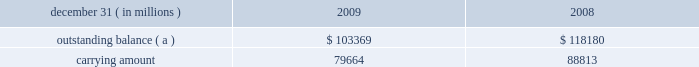Notes to consolidated financial statements jpmorgan chase & co./2009 annual report 204 on the amount of interest income recognized in the firm 2019s consolidated statements of income since that date .
( b ) other changes in expected cash flows include the net impact of changes in esti- mated prepayments and reclassifications to the nonaccretable difference .
On a quarterly basis , the firm updates the amount of loan principal and interest cash flows expected to be collected , incorporating assumptions regarding default rates , loss severities , the amounts and timing of prepayments and other factors that are reflective of current market conditions .
Probable decreases in expected loan principal cash flows trigger the recognition of impairment , which is then measured as the present value of the expected principal loss plus any related foregone interest cash flows discounted at the pool 2019s effective interest rate .
Impairments that occur after the acquisition date are recognized through the provision and allow- ance for loan losses .
Probable and significant increases in expected principal cash flows would first reverse any previously recorded allowance for loan losses ; any remaining increases are recognized prospectively as interest income .
The impacts of ( i ) prepayments , ( ii ) changes in variable interest rates , and ( iii ) any other changes in the timing of expected cash flows are recognized prospectively as adjustments to interest income .
Disposals of loans , which may include sales of loans , receipt of payments in full by the borrower , or foreclosure , result in removal of the loan from the purchased credit-impaired portfolio .
If the timing and/or amounts of expected cash flows on these purchased credit-impaired loans were determined not to be rea- sonably estimable , no interest would be accreted and the loans would be reported as nonperforming loans ; however , since the timing and amounts of expected cash flows for these purchased credit-impaired loans are reasonably estimable , interest is being accreted and the loans are being reported as performing loans .
Charge-offs are not recorded on purchased credit-impaired loans until actual losses exceed the estimated losses that were recorded as purchase accounting adjustments at acquisition date .
To date , no charge-offs have been recorded for these loans .
Purchased credit-impaired loans acquired in the washington mu- tual transaction are reported in loans on the firm 2019s consolidated balance sheets .
In 2009 , an allowance for loan losses of $ 1.6 billion was recorded for the prime mortgage and option arm pools of loans .
The net aggregate carrying amount of the pools that have an allowance for loan losses was $ 47.2 billion at december 31 , 2009 .
This allowance for loan losses is reported as a reduction of the carrying amount of the loans in the table below .
The table below provides additional information about these pur- chased credit-impaired consumer loans. .
( a ) represents the sum of contractual principal , interest and fees earned at the reporting date .
Purchased credit-impaired loans are also being modified under the mha programs and the firm 2019s other loss mitigation programs .
For these loans , the impact of the modification is incorporated into the firm 2019s quarterly assessment of whether a probable and/or signifi- cant change in estimated future cash flows has occurred , and the loans continue to be accounted for as and reported as purchased credit-impaired loans .
Foreclosed property the firm acquires property from borrowers through loan restructur- ings , workouts , and foreclosures , which is recorded in other assets on the consolidated balance sheets .
Property acquired may include real property ( e.g. , land , buildings , and fixtures ) and commercial and personal property ( e.g. , aircraft , railcars , and ships ) .
Acquired property is valued at fair value less costs to sell at acquisition .
Each quarter the fair value of the acquired property is reviewed and adjusted , if necessary .
Any adjustments to fair value in the first 90 days are charged to the allowance for loan losses and thereafter adjustments are charged/credited to noninterest revenue 2013other .
Operating expense , such as real estate taxes and maintenance , are charged to other expense .
Note 14 2013 allowance for credit losses the allowance for loan losses includes an asset-specific component , a formula-based component and a component related to purchased credit-impaired loans .
The asset-specific component relates to loans considered to be impaired , which includes any loans that have been modified in a troubled debt restructuring as well as risk-rated loans that have been placed on nonaccrual status .
An asset-specific allowance for impaired loans is established when the loan 2019s discounted cash flows ( or , when available , the loan 2019s observable market price ) is lower than the recorded investment in the loan .
To compute the asset-specific component of the allowance , larger loans are evaluated individually , while smaller loans are evaluated as pools using historical loss experience for the respective class of assets .
Risk-rated loans ( primarily wholesale loans ) are pooled by risk rating , while scored loans ( i.e. , consumer loans ) are pooled by product type .
The firm generally measures the asset-specific allowance as the difference between the recorded investment in the loan and the present value of the cash flows expected to be collected , dis- counted at the loan 2019s original effective interest rate .
Subsequent changes in measured impairment due to the impact of discounting are reported as an adjustment to the provision for loan losses , not as an adjustment to interest income .
An asset-specific allowance for an impaired loan with an observable market price is measured as the difference between the recorded investment in the loan and the loan 2019s fair value .
Certain impaired loans that are determined to be collateral- dependent are charged-off to the fair value of the collateral less costs to sell .
When collateral-dependent commercial real-estate loans are determined to be impaired , updated appraisals are typi- cally obtained and updated every six to twelve months .
The firm also considers both borrower- and market-specific factors , which .
What was the ratio of the allowance for loan losses that was recorded for the prime mortgage to the net aggregate carrying amount of the pools? 
Computations: (1.6 / 47.2)
Answer: 0.0339. Notes to consolidated financial statements jpmorgan chase & co./2009 annual report 204 on the amount of interest income recognized in the firm 2019s consolidated statements of income since that date .
( b ) other changes in expected cash flows include the net impact of changes in esti- mated prepayments and reclassifications to the nonaccretable difference .
On a quarterly basis , the firm updates the amount of loan principal and interest cash flows expected to be collected , incorporating assumptions regarding default rates , loss severities , the amounts and timing of prepayments and other factors that are reflective of current market conditions .
Probable decreases in expected loan principal cash flows trigger the recognition of impairment , which is then measured as the present value of the expected principal loss plus any related foregone interest cash flows discounted at the pool 2019s effective interest rate .
Impairments that occur after the acquisition date are recognized through the provision and allow- ance for loan losses .
Probable and significant increases in expected principal cash flows would first reverse any previously recorded allowance for loan losses ; any remaining increases are recognized prospectively as interest income .
The impacts of ( i ) prepayments , ( ii ) changes in variable interest rates , and ( iii ) any other changes in the timing of expected cash flows are recognized prospectively as adjustments to interest income .
Disposals of loans , which may include sales of loans , receipt of payments in full by the borrower , or foreclosure , result in removal of the loan from the purchased credit-impaired portfolio .
If the timing and/or amounts of expected cash flows on these purchased credit-impaired loans were determined not to be rea- sonably estimable , no interest would be accreted and the loans would be reported as nonperforming loans ; however , since the timing and amounts of expected cash flows for these purchased credit-impaired loans are reasonably estimable , interest is being accreted and the loans are being reported as performing loans .
Charge-offs are not recorded on purchased credit-impaired loans until actual losses exceed the estimated losses that were recorded as purchase accounting adjustments at acquisition date .
To date , no charge-offs have been recorded for these loans .
Purchased credit-impaired loans acquired in the washington mu- tual transaction are reported in loans on the firm 2019s consolidated balance sheets .
In 2009 , an allowance for loan losses of $ 1.6 billion was recorded for the prime mortgage and option arm pools of loans .
The net aggregate carrying amount of the pools that have an allowance for loan losses was $ 47.2 billion at december 31 , 2009 .
This allowance for loan losses is reported as a reduction of the carrying amount of the loans in the table below .
The table below provides additional information about these pur- chased credit-impaired consumer loans. .
( a ) represents the sum of contractual principal , interest and fees earned at the reporting date .
Purchased credit-impaired loans are also being modified under the mha programs and the firm 2019s other loss mitigation programs .
For these loans , the impact of the modification is incorporated into the firm 2019s quarterly assessment of whether a probable and/or signifi- cant change in estimated future cash flows has occurred , and the loans continue to be accounted for as and reported as purchased credit-impaired loans .
Foreclosed property the firm acquires property from borrowers through loan restructur- ings , workouts , and foreclosures , which is recorded in other assets on the consolidated balance sheets .
Property acquired may include real property ( e.g. , land , buildings , and fixtures ) and commercial and personal property ( e.g. , aircraft , railcars , and ships ) .
Acquired property is valued at fair value less costs to sell at acquisition .
Each quarter the fair value of the acquired property is reviewed and adjusted , if necessary .
Any adjustments to fair value in the first 90 days are charged to the allowance for loan losses and thereafter adjustments are charged/credited to noninterest revenue 2013other .
Operating expense , such as real estate taxes and maintenance , are charged to other expense .
Note 14 2013 allowance for credit losses the allowance for loan losses includes an asset-specific component , a formula-based component and a component related to purchased credit-impaired loans .
The asset-specific component relates to loans considered to be impaired , which includes any loans that have been modified in a troubled debt restructuring as well as risk-rated loans that have been placed on nonaccrual status .
An asset-specific allowance for impaired loans is established when the loan 2019s discounted cash flows ( or , when available , the loan 2019s observable market price ) is lower than the recorded investment in the loan .
To compute the asset-specific component of the allowance , larger loans are evaluated individually , while smaller loans are evaluated as pools using historical loss experience for the respective class of assets .
Risk-rated loans ( primarily wholesale loans ) are pooled by risk rating , while scored loans ( i.e. , consumer loans ) are pooled by product type .
The firm generally measures the asset-specific allowance as the difference between the recorded investment in the loan and the present value of the cash flows expected to be collected , dis- counted at the loan 2019s original effective interest rate .
Subsequent changes in measured impairment due to the impact of discounting are reported as an adjustment to the provision for loan losses , not as an adjustment to interest income .
An asset-specific allowance for an impaired loan with an observable market price is measured as the difference between the recorded investment in the loan and the loan 2019s fair value .
Certain impaired loans that are determined to be collateral- dependent are charged-off to the fair value of the collateral less costs to sell .
When collateral-dependent commercial real-estate loans are determined to be impaired , updated appraisals are typi- cally obtained and updated every six to twelve months .
The firm also considers both borrower- and market-specific factors , which .
In 2009 , what percentage of its net aggregate carrying amount did the firm record as its allowance for loan losses? 
Rationale: the firm's allowance for loan losses , $ 1.6 billion , came from an aggregate pool of $ 47.2 billion .
Computations: (1.6 / 47.2)
Answer: 0.0339. Notes to consolidated financial statements jpmorgan chase & co./2009 annual report 204 on the amount of interest income recognized in the firm 2019s consolidated statements of income since that date .
( b ) other changes in expected cash flows include the net impact of changes in esti- mated prepayments and reclassifications to the nonaccretable difference .
On a quarterly basis , the firm updates the amount of loan principal and interest cash flows expected to be collected , incorporating assumptions regarding default rates , loss severities , the amounts and timing of prepayments and other factors that are reflective of current market conditions .
Probable decreases in expected loan principal cash flows trigger the recognition of impairment , which is then measured as the present value of the expected principal loss plus any related foregone interest cash flows discounted at the pool 2019s effective interest rate .
Impairments that occur after the acquisition date are recognized through the provision and allow- ance for loan losses .
Probable and significant increases in expected principal cash flows would first reverse any previously recorded allowance for loan losses ; any remaining increases are recognized prospectively as interest income .
The impacts of ( i ) prepayments , ( ii ) changes in variable interest rates , and ( iii ) any other changes in the timing of expected cash flows are recognized prospectively as adjustments to interest income .
Disposals of loans , which may include sales of loans , receipt of payments in full by the borrower , or foreclosure , result in removal of the loan from the purchased credit-impaired portfolio .
If the timing and/or amounts of expected cash flows on these purchased credit-impaired loans were determined not to be rea- sonably estimable , no interest would be accreted and the loans would be reported as nonperforming loans ; however , since the timing and amounts of expected cash flows for these purchased credit-impaired loans are reasonably estimable , interest is being accreted and the loans are being reported as performing loans .
Charge-offs are not recorded on purchased credit-impaired loans until actual losses exceed the estimated losses that were recorded as purchase accounting adjustments at acquisition date .
To date , no charge-offs have been recorded for these loans .
Purchased credit-impaired loans acquired in the washington mu- tual transaction are reported in loans on the firm 2019s consolidated balance sheets .
In 2009 , an allowance for loan losses of $ 1.6 billion was recorded for the prime mortgage and option arm pools of loans .
The net aggregate carrying amount of the pools that have an allowance for loan losses was $ 47.2 billion at december 31 , 2009 .
This allowance for loan losses is reported as a reduction of the carrying amount of the loans in the table below .
The table below provides additional information about these pur- chased credit-impaired consumer loans. .
( a ) represents the sum of contractual principal , interest and fees earned at the reporting date .
Purchased credit-impaired loans are also being modified under the mha programs and the firm 2019s other loss mitigation programs .
For these loans , the impact of the modification is incorporated into the firm 2019s quarterly assessment of whether a probable and/or signifi- cant change in estimated future cash flows has occurred , and the loans continue to be accounted for as and reported as purchased credit-impaired loans .
Foreclosed property the firm acquires property from borrowers through loan restructur- ings , workouts , and foreclosures , which is recorded in other assets on the consolidated balance sheets .
Property acquired may include real property ( e.g. , land , buildings , and fixtures ) and commercial and personal property ( e.g. , aircraft , railcars , and ships ) .
Acquired property is valued at fair value less costs to sell at acquisition .
Each quarter the fair value of the acquired property is reviewed and adjusted , if necessary .
Any adjustments to fair value in the first 90 days are charged to the allowance for loan losses and thereafter adjustments are charged/credited to noninterest revenue 2013other .
Operating expense , such as real estate taxes and maintenance , are charged to other expense .
Note 14 2013 allowance for credit losses the allowance for loan losses includes an asset-specific component , a formula-based component and a component related to purchased credit-impaired loans .
The asset-specific component relates to loans considered to be impaired , which includes any loans that have been modified in a troubled debt restructuring as well as risk-rated loans that have been placed on nonaccrual status .
An asset-specific allowance for impaired loans is established when the loan 2019s discounted cash flows ( or , when available , the loan 2019s observable market price ) is lower than the recorded investment in the loan .
To compute the asset-specific component of the allowance , larger loans are evaluated individually , while smaller loans are evaluated as pools using historical loss experience for the respective class of assets .
Risk-rated loans ( primarily wholesale loans ) are pooled by risk rating , while scored loans ( i.e. , consumer loans ) are pooled by product type .
The firm generally measures the asset-specific allowance as the difference between the recorded investment in the loan and the present value of the cash flows expected to be collected , dis- counted at the loan 2019s original effective interest rate .
Subsequent changes in measured impairment due to the impact of discounting are reported as an adjustment to the provision for loan losses , not as an adjustment to interest income .
An asset-specific allowance for an impaired loan with an observable market price is measured as the difference between the recorded investment in the loan and the loan 2019s fair value .
Certain impaired loans that are determined to be collateral- dependent are charged-off to the fair value of the collateral less costs to sell .
When collateral-dependent commercial real-estate loans are determined to be impaired , updated appraisals are typi- cally obtained and updated every six to twelve months .
The firm also considers both borrower- and market-specific factors , which .
What was the firm's average sum of contractual principal , interest and fees in 2008 and 2009? 
Rationale: add the two total sums from 2008 and 2009 and then divide by the total number of years ( 2 ) for the average .
Computations: ((103369 + 118180) / 2)
Answer: 110774.5. Notes to consolidated financial statements jpmorgan chase & co./2009 annual report 204 on the amount of interest income recognized in the firm 2019s consolidated statements of income since that date .
( b ) other changes in expected cash flows include the net impact of changes in esti- mated prepayments and reclassifications to the nonaccretable difference .
On a quarterly basis , the firm updates the amount of loan principal and interest cash flows expected to be collected , incorporating assumptions regarding default rates , loss severities , the amounts and timing of prepayments and other factors that are reflective of current market conditions .
Probable decreases in expected loan principal cash flows trigger the recognition of impairment , which is then measured as the present value of the expected principal loss plus any related foregone interest cash flows discounted at the pool 2019s effective interest rate .
Impairments that occur after the acquisition date are recognized through the provision and allow- ance for loan losses .
Probable and significant increases in expected principal cash flows would first reverse any previously recorded allowance for loan losses ; any remaining increases are recognized prospectively as interest income .
The impacts of ( i ) prepayments , ( ii ) changes in variable interest rates , and ( iii ) any other changes in the timing of expected cash flows are recognized prospectively as adjustments to interest income .
Disposals of loans , which may include sales of loans , receipt of payments in full by the borrower , or foreclosure , result in removal of the loan from the purchased credit-impaired portfolio .
If the timing and/or amounts of expected cash flows on these purchased credit-impaired loans were determined not to be rea- sonably estimable , no interest would be accreted and the loans would be reported as nonperforming loans ; however , since the timing and amounts of expected cash flows for these purchased credit-impaired loans are reasonably estimable , interest is being accreted and the loans are being reported as performing loans .
Charge-offs are not recorded on purchased credit-impaired loans until actual losses exceed the estimated losses that were recorded as purchase accounting adjustments at acquisition date .
To date , no charge-offs have been recorded for these loans .
Purchased credit-impaired loans acquired in the washington mu- tual transaction are reported in loans on the firm 2019s consolidated balance sheets .
In 2009 , an allowance for loan losses of $ 1.6 billion was recorded for the prime mortgage and option arm pools of loans .
The net aggregate carrying amount of the pools that have an allowance for loan losses was $ 47.2 billion at december 31 , 2009 .
This allowance for loan losses is reported as a reduction of the carrying amount of the loans in the table below .
The table below provides additional information about these pur- chased credit-impaired consumer loans. .
( a ) represents the sum of contractual principal , interest and fees earned at the reporting date .
Purchased credit-impaired loans are also being modified under the mha programs and the firm 2019s other loss mitigation programs .
For these loans , the impact of the modification is incorporated into the firm 2019s quarterly assessment of whether a probable and/or signifi- cant change in estimated future cash flows has occurred , and the loans continue to be accounted for as and reported as purchased credit-impaired loans .
Foreclosed property the firm acquires property from borrowers through loan restructur- ings , workouts , and foreclosures , which is recorded in other assets on the consolidated balance sheets .
Property acquired may include real property ( e.g. , land , buildings , and fixtures ) and commercial and personal property ( e.g. , aircraft , railcars , and ships ) .
Acquired property is valued at fair value less costs to sell at acquisition .
Each quarter the fair value of the acquired property is reviewed and adjusted , if necessary .
Any adjustments to fair value in the first 90 days are charged to the allowance for loan losses and thereafter adjustments are charged/credited to noninterest revenue 2013other .
Operating expense , such as real estate taxes and maintenance , are charged to other expense .
Note 14 2013 allowance for credit losses the allowance for loan losses includes an asset-specific component , a formula-based component and a component related to purchased credit-impaired loans .
The asset-specific component relates to loans considered to be impaired , which includes any loans that have been modified in a troubled debt restructuring as well as risk-rated loans that have been placed on nonaccrual status .
An asset-specific allowance for impaired loans is established when the loan 2019s discounted cash flows ( or , when available , the loan 2019s observable market price ) is lower than the recorded investment in the loan .
To compute the asset-specific component of the allowance , larger loans are evaluated individually , while smaller loans are evaluated as pools using historical loss experience for the respective class of assets .
Risk-rated loans ( primarily wholesale loans ) are pooled by risk rating , while scored loans ( i.e. , consumer loans ) are pooled by product type .
The firm generally measures the asset-specific allowance as the difference between the recorded investment in the loan and the present value of the cash flows expected to be collected , dis- counted at the loan 2019s original effective interest rate .
Subsequent changes in measured impairment due to the impact of discounting are reported as an adjustment to the provision for loan losses , not as an adjustment to interest income .
An asset-specific allowance for an impaired loan with an observable market price is measured as the difference between the recorded investment in the loan and the loan 2019s fair value .
Certain impaired loans that are determined to be collateral- dependent are charged-off to the fair value of the collateral less costs to sell .
When collateral-dependent commercial real-estate loans are determined to be impaired , updated appraisals are typi- cally obtained and updated every six to twelve months .
The firm also considers both borrower- and market-specific factors , which .
For 2009 , what is the average reserve percentage for the prime mortgage and option arm pools of loans?\\n\\n? 
Computations: (1.6 / 47.2)
Answer: 0.0339. Notes to consolidated financial statements jpmorgan chase & co./2009 annual report 204 on the amount of interest income recognized in the firm 2019s consolidated statements of income since that date .
( b ) other changes in expected cash flows include the net impact of changes in esti- mated prepayments and reclassifications to the nonaccretable difference .
On a quarterly basis , the firm updates the amount of loan principal and interest cash flows expected to be collected , incorporating assumptions regarding default rates , loss severities , the amounts and timing of prepayments and other factors that are reflective of current market conditions .
Probable decreases in expected loan principal cash flows trigger the recognition of impairment , which is then measured as the present value of the expected principal loss plus any related foregone interest cash flows discounted at the pool 2019s effective interest rate .
Impairments that occur after the acquisition date are recognized through the provision and allow- ance for loan losses .
Probable and significant increases in expected principal cash flows would first reverse any previously recorded allowance for loan losses ; any remaining increases are recognized prospectively as interest income .
The impacts of ( i ) prepayments , ( ii ) changes in variable interest rates , and ( iii ) any other changes in the timing of expected cash flows are recognized prospectively as adjustments to interest income .
Disposals of loans , which may include sales of loans , receipt of payments in full by the borrower , or foreclosure , result in removal of the loan from the purchased credit-impaired portfolio .
If the timing and/or amounts of expected cash flows on these purchased credit-impaired loans were determined not to be rea- sonably estimable , no interest would be accreted and the loans would be reported as nonperforming loans ; however , since the timing and amounts of expected cash flows for these purchased credit-impaired loans are reasonably estimable , interest is being accreted and the loans are being reported as performing loans .
Charge-offs are not recorded on purchased credit-impaired loans until actual losses exceed the estimated losses that were recorded as purchase accounting adjustments at acquisition date .
To date , no charge-offs have been recorded for these loans .
Purchased credit-impaired loans acquired in the washington mu- tual transaction are reported in loans on the firm 2019s consolidated balance sheets .
In 2009 , an allowance for loan losses of $ 1.6 billion was recorded for the prime mortgage and option arm pools of loans .
The net aggregate carrying amount of the pools that have an allowance for loan losses was $ 47.2 billion at december 31 , 2009 .
This allowance for loan losses is reported as a reduction of the carrying amount of the loans in the table below .
The table below provides additional information about these pur- chased credit-impaired consumer loans. .
( a ) represents the sum of contractual principal , interest and fees earned at the reporting date .
Purchased credit-impaired loans are also being modified under the mha programs and the firm 2019s other loss mitigation programs .
For these loans , the impact of the modification is incorporated into the firm 2019s quarterly assessment of whether a probable and/or signifi- cant change in estimated future cash flows has occurred , and the loans continue to be accounted for as and reported as purchased credit-impaired loans .
Foreclosed property the firm acquires property from borrowers through loan restructur- ings , workouts , and foreclosures , which is recorded in other assets on the consolidated balance sheets .
Property acquired may include real property ( e.g. , land , buildings , and fixtures ) and commercial and personal property ( e.g. , aircraft , railcars , and ships ) .
Acquired property is valued at fair value less costs to sell at acquisition .
Each quarter the fair value of the acquired property is reviewed and adjusted , if necessary .
Any adjustments to fair value in the first 90 days are charged to the allowance for loan losses and thereafter adjustments are charged/credited to noninterest revenue 2013other .
Operating expense , such as real estate taxes and maintenance , are charged to other expense .
Note 14 2013 allowance for credit losses the allowance for loan losses includes an asset-specific component , a formula-based component and a component related to purchased credit-impaired loans .
The asset-specific component relates to loans considered to be impaired , which includes any loans that have been modified in a troubled debt restructuring as well as risk-rated loans that have been placed on nonaccrual status .
An asset-specific allowance for impaired loans is established when the loan 2019s discounted cash flows ( or , when available , the loan 2019s observable market price ) is lower than the recorded investment in the loan .
To compute the asset-specific component of the allowance , larger loans are evaluated individually , while smaller loans are evaluated as pools using historical loss experience for the respective class of assets .
Risk-rated loans ( primarily wholesale loans ) are pooled by risk rating , while scored loans ( i.e. , consumer loans ) are pooled by product type .
The firm generally measures the asset-specific allowance as the difference between the recorded investment in the loan and the present value of the cash flows expected to be collected , dis- counted at the loan 2019s original effective interest rate .
Subsequent changes in measured impairment due to the impact of discounting are reported as an adjustment to the provision for loan losses , not as an adjustment to interest income .
An asset-specific allowance for an impaired loan with an observable market price is measured as the difference between the recorded investment in the loan and the loan 2019s fair value .
Certain impaired loans that are determined to be collateral- dependent are charged-off to the fair value of the collateral less costs to sell .
When collateral-dependent commercial real-estate loans are determined to be impaired , updated appraisals are typi- cally obtained and updated every six to twelve months .
The firm also considers both borrower- and market-specific factors , which .
For 2009 , what was the net reserve allowance on the prime mortgage and option arm pools of loans , in millions?\\n? 
Computations: (103369 - 79664)
Answer: 23705.0. 